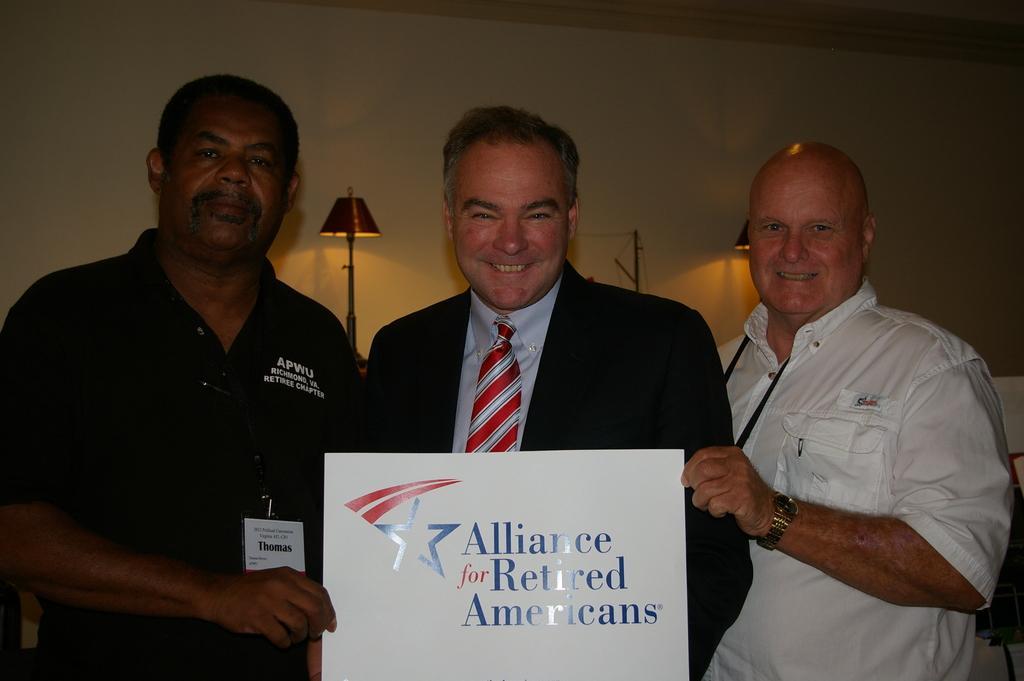How would you summarize this image in a sentence or two? On the left side, there is a person with a green color T-shirt, wearing a badge and holding a certificate with a hand. Beside him, there is another person in a suit, smiling and standing. On the right side, there is a person in a white color t-shirt, smiling, holding this certificate and standing. In the background, there are two lights arranged and there is a wall. 